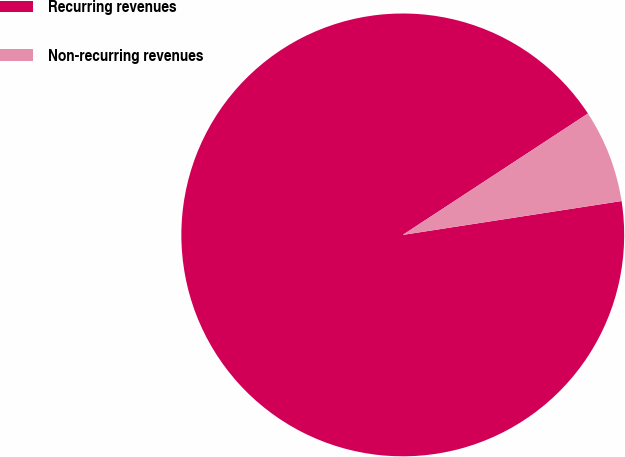Convert chart. <chart><loc_0><loc_0><loc_500><loc_500><pie_chart><fcel>Recurring revenues<fcel>Non-recurring revenues<nl><fcel>93.21%<fcel>6.79%<nl></chart> 